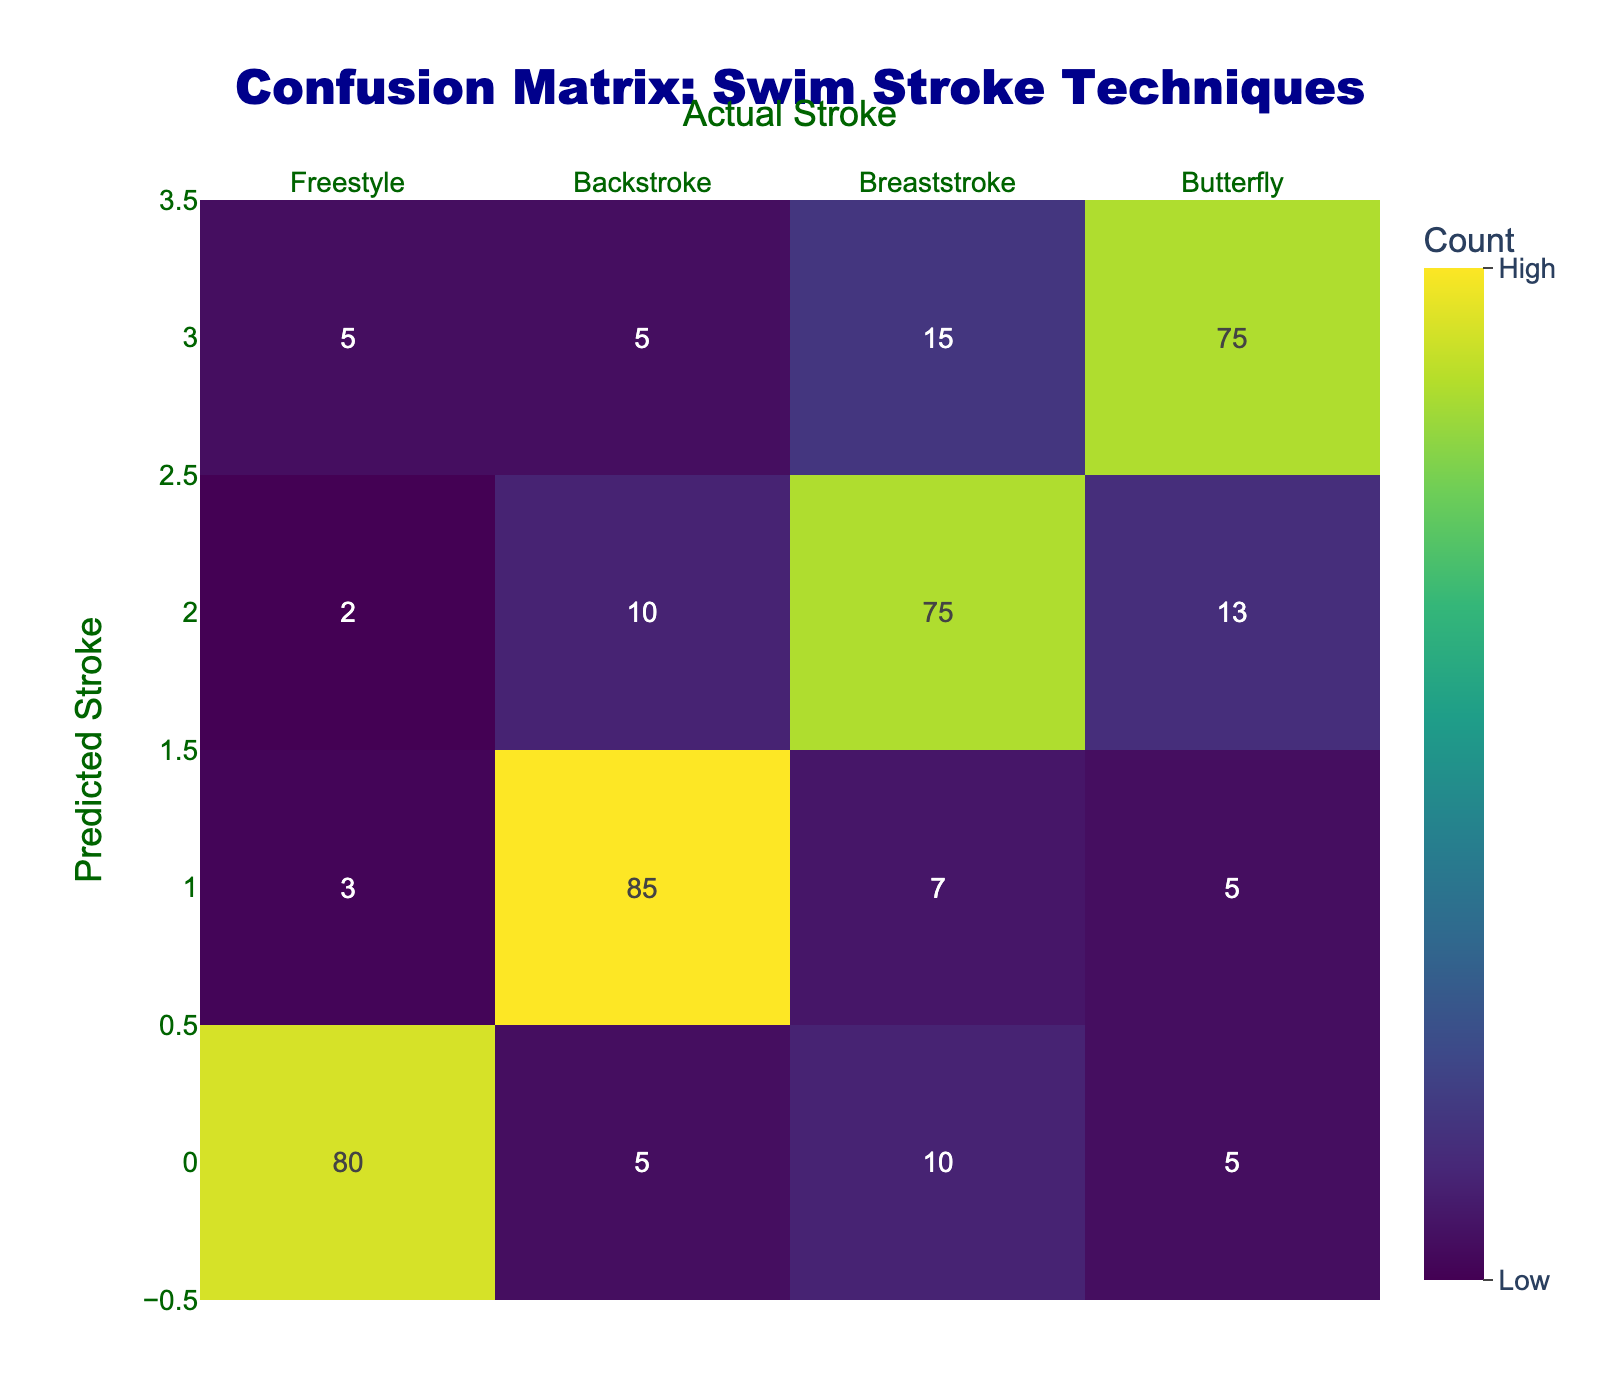What is the number of predictions for Freestyle? To find this, look at the "Predicted Freestyle" row to see the counts of each actual stroke predicted as Freestyle. From the row: Freestyle - 80, Backstroke - 3, Breaststroke - 2, Butterfly - 5, we sum these values: 80 + 3 + 2 + 5 = 90.
Answer: 90 What is the number of strokes correctly predicted as Backstroke? The correct predictions for Backstroke are located at the intersection of the "Predicted Backstroke" row and "Actual Stroke" column for Backstroke. Here, the value is 85.
Answer: 85 Are there more misclassifications for Breaststroke than for Freestyle? First, check the misclassifications in both rows; for Breaststroke: Backstroke (10) + Freestyle (2) + Butterfly (13) = 25 misclassifications. For Freestyle: Backstroke (5) + Breaststroke (10) + Butterfly (5) = 20. Since 25 > 20, it is true.
Answer: Yes What is the total number of predicted strokes for Butterfly? To find this total, look for "Predicted Butterfly" row again. Sum the values: Freestyle - 5, Backstroke - 5, Breaststroke - 15, Butterfly - 75. Hence, total predictions = 5 + 5 + 15 + 75 = 100.
Answer: 100 What is the confusion rate for Backstroke predictions? The confusion rate is calculated as the sum of misclassifications divided by the total predictions. Misclassifications: Freestyle (3) + Breaststroke (7) + Butterfly (5) = 15. Total predictions = 90. Therefore, confusion rate = 15/90 = 0.1667, or approximately 16.67%.
Answer: 16.67% How many actual strokes were misclassified as Butterfly? To find the misclassifications to Butterfly, follow the "Predicted Butterfly" row and count the misclassified values: actual Freestyle predicted as Butterfly (5), Backstroke (5), and Breaststroke (15). This totals 25 strokes misclassified as Butterfly.
Answer: 25 What is the difference between the correct predictions for Freestyle and Backstroke? For Freestyle, correct predictions are 80, and for Backstroke, correct predictions are 85. The difference is calculated as 85 - 80 = 5.
Answer: 5 Is the predicted performance for Backstroke better than that of Breaststroke? To evaluate, consider the correct predictions: Backstroke has 85, while Breaststroke has 75. Since 85 > 75, it can be concluded that Backstroke has a better predicted performance than Breaststroke.
Answer: Yes 